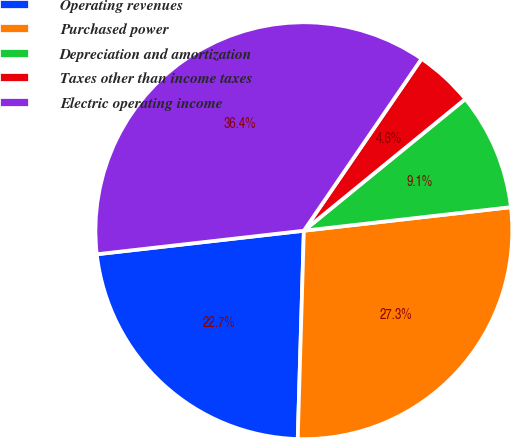Convert chart to OTSL. <chart><loc_0><loc_0><loc_500><loc_500><pie_chart><fcel>Operating revenues<fcel>Purchased power<fcel>Depreciation and amortization<fcel>Taxes other than income taxes<fcel>Electric operating income<nl><fcel>22.73%<fcel>27.27%<fcel>9.09%<fcel>4.55%<fcel>36.36%<nl></chart> 